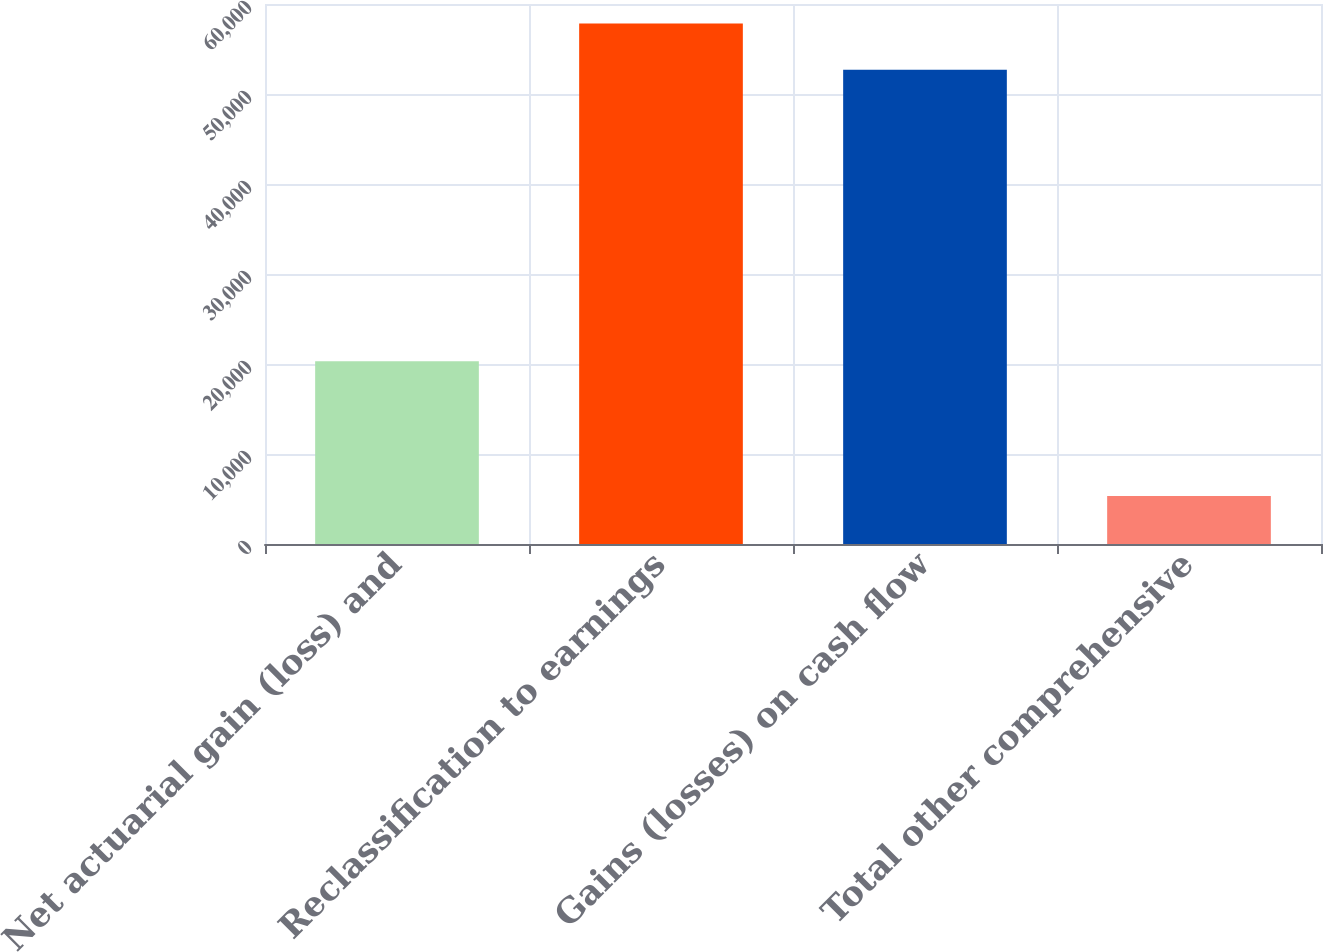Convert chart to OTSL. <chart><loc_0><loc_0><loc_500><loc_500><bar_chart><fcel>Net actuarial gain (loss) and<fcel>Reclassification to earnings<fcel>Gains (losses) on cash flow<fcel>Total other comprehensive<nl><fcel>20304<fcel>57836.1<fcel>52708<fcel>5323<nl></chart> 